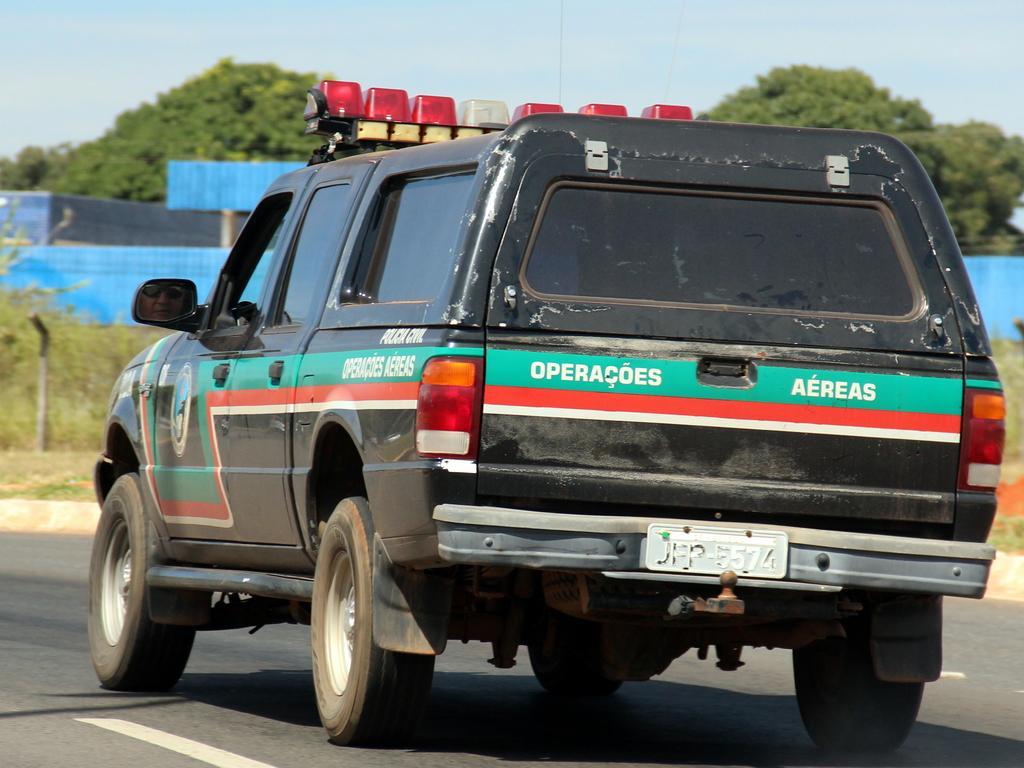In one or two sentences, can you explain what this image depicts? In this image we can see the vehicle. And we can see the road. And we can see the pole. And in the background can see one shed. And we can see trees. And we can see the sky. 